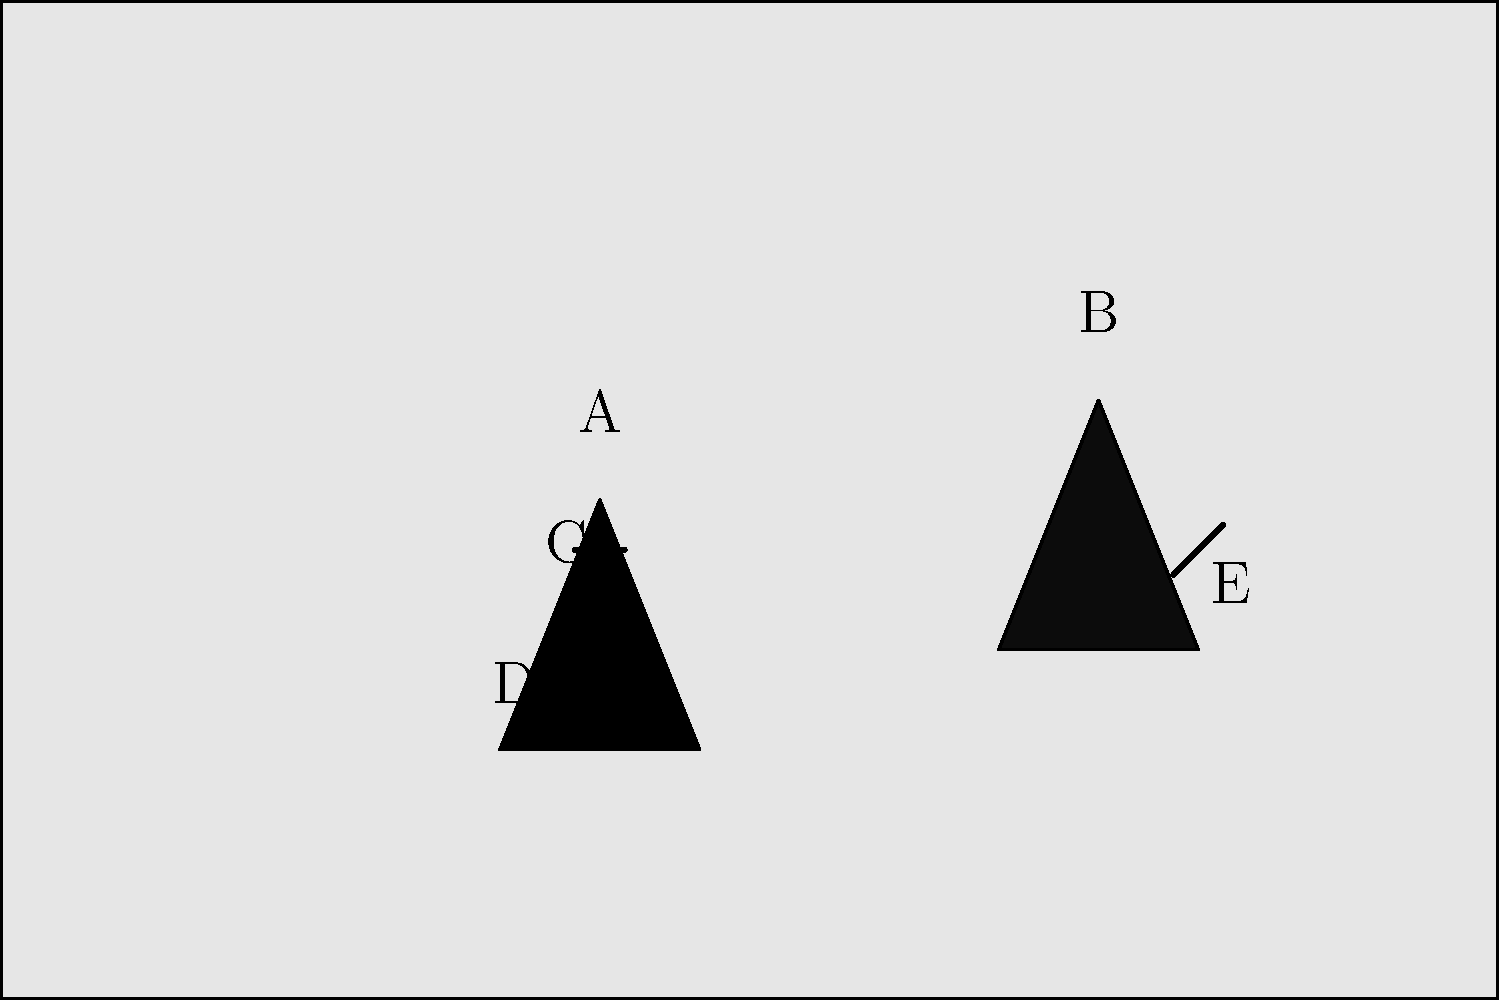In the given police body camera footage screenshot, identify the elements labeled A through E. Which of these elements is most crucial for documenting potential police misconduct? To answer this question, let's analyze each labeled element in the image:

1. Element A: This represents the police officer's body, identifiable by its position and the dark uniform color.

2. Element B: This represents the suspect or civilian involved in the interaction, recognizable by its different shape and position opposite the officer.

3. Element C: This small rectangular shape on the officer's chest area represents the body camera itself, which is recording the incident.

4. Element D: The small circular shape on the officer's chest likely represents the officer's badge, an important identifier.

5. Element E: The angular shape near the suspect's hand area could represent a potential weapon or object of interest in the situation.

When considering potential police misconduct, the most crucial element for documentation is C, the body camera. Here's why:

1. Objective evidence: The body camera provides an unbiased, real-time recording of the entire interaction.

2. Accountability: It ensures that both the officer's and civilian's actions are captured, promoting accountability.

3. Protection for both parties: It can protect both the officer from false accusations and the civilian from potential misconduct.

4. Legal value: Footage from body cameras is often admissible in court and can be critical in legal proceedings.

5. Transparency: Body camera footage promotes transparency in police operations and helps build public trust.

While other elements like the officer's badge (D) or a potential weapon (E) are important, they don't provide the comprehensive documentation that a body camera does in cases of potential misconduct.
Answer: C (Body camera) 